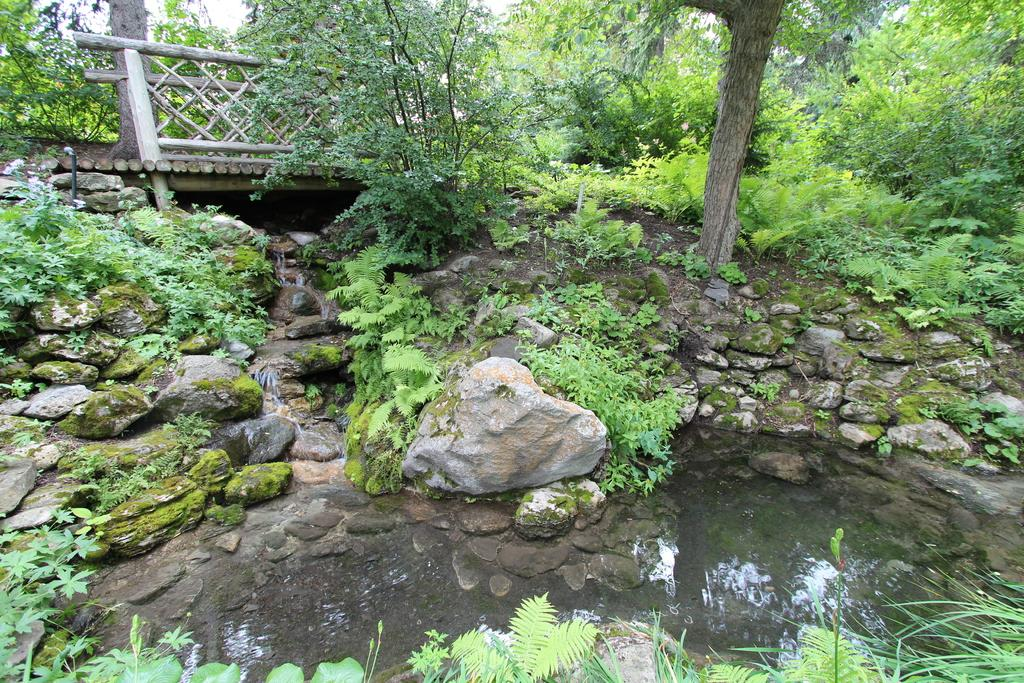What is the primary element visible in the image? There is water in the image. What surrounds the water in the image? There are rocks and plants around the water. What type of barrier can be seen in the image? There is a fence in the image. What can be seen in the distance in the image? There are trees in the background of the image. How does the rock increase in size throughout the image? There is no rock present in the image, so it cannot increase in size. 